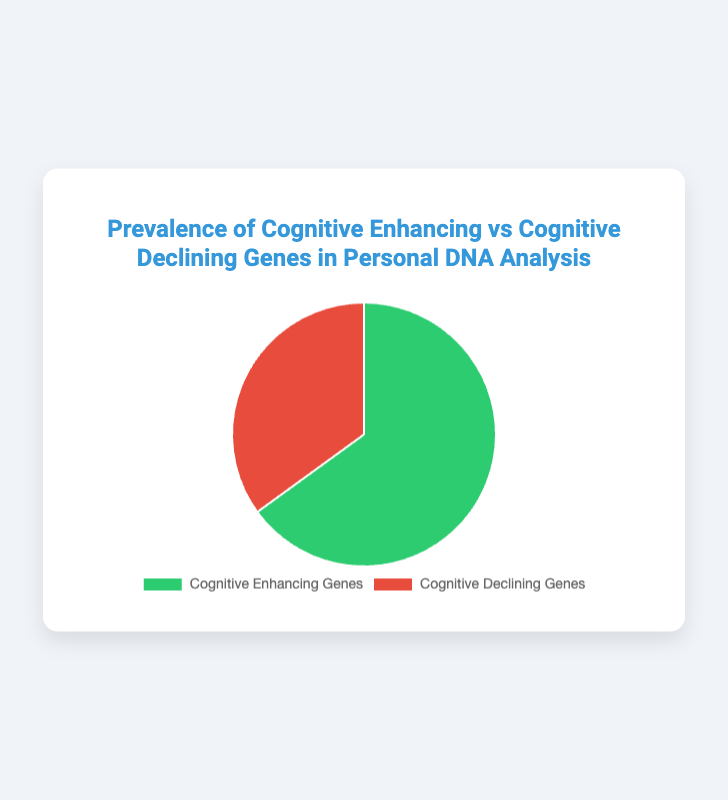Which type of genes is more prevalent in the DNA analysis? The pie chart shows two gene types: Cognitive Enhancing Genes and Cognitive Declining Genes. The section representing Cognitive Enhancing Genes is larger, indicating it is more prevalent.
Answer: Cognitive Enhancing Genes What is the exact percentage of Cognitive Enhancing Genes? The chart legend indicates that Cognitive Enhancing Genes account for 65% of the total. This is directly shown in the chart data.
Answer: 65% What percentage of the genes analyzed are cognitive declining? The legend indicates that Cognitive Declining Genes account for 35% of the total. This is clearly shown in the chart data.
Answer: 35% How much more prevalent are Cognitive Enhancing Genes compared to Cognitive Declining Genes? Cognitive Enhancing Genes are at 65%, while Cognitive Declining Genes are at 35%. The difference between them is calculated as 65% - 35% = 30%.
Answer: 30% What are the colors representing Cognitive Enhancing and Declining Genes? The pie chart uses green to represent Cognitive Enhancing Genes and red to depict Cognitive Declining Genes. This information can be inferred from visual inspection of the chart.
Answer: Green for Cognitive Enhancing, Red for Cognitive Declining If there were 200 gene sequences analyzed, how many were Cognitive Enhancing Genes? If 65% of the genes are Cognitive Enhancing and there are 200 genes in total, then 0.65 * 200 = 130 genes are Cognitive Enhancing.
Answer: 130 What part of the chart displays the Cognitive Declining Genes? The Cognitive Declining Genes are represented by the red section and cover a smaller portion of the pie chart compared to the green section.
Answer: The red section If a new analysis showed a 5% increase in Cognitive Declining Genes, what would the new percentage be? Initially, Cognitive Declining Genes are at 35%. An increase of 5% would make it 35% + 5% = 40%.
Answer: 40% Compare the ratio of Cognitive Enhancing Genes to Cognitive Declining Genes. To find the ratio, we divide the percentages: 65% / 35%. This simplifies to 13:7.
Answer: 13:7 How many more people have Cognitive Enhancing Genes than Cognitive Declining Genes if the total sample size is 100 people? With Cognitive Enhancing Genes at 65%, it implies 65 people have enhancing genes. For declining genes at 35%, it implies 35 people have declining genes. The difference is 65 - 35 = 30 people.
Answer: 30 